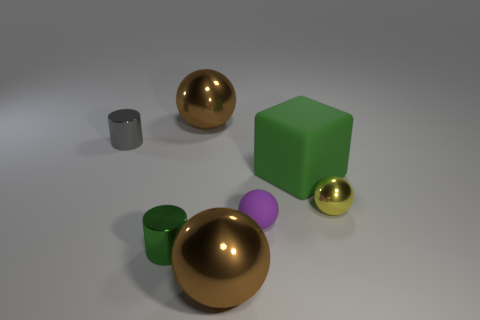Subtract 1 spheres. How many spheres are left? 3 Subtract all metal spheres. How many spheres are left? 1 Subtract all purple spheres. How many spheres are left? 3 Subtract all blue balls. Subtract all yellow blocks. How many balls are left? 4 Add 1 blue objects. How many objects exist? 8 Subtract all spheres. How many objects are left? 3 Add 1 matte blocks. How many matte blocks exist? 2 Subtract 0 green balls. How many objects are left? 7 Subtract all tiny brown cubes. Subtract all small purple objects. How many objects are left? 6 Add 6 large green blocks. How many large green blocks are left? 7 